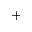<formula> <loc_0><loc_0><loc_500><loc_500>+</formula> 